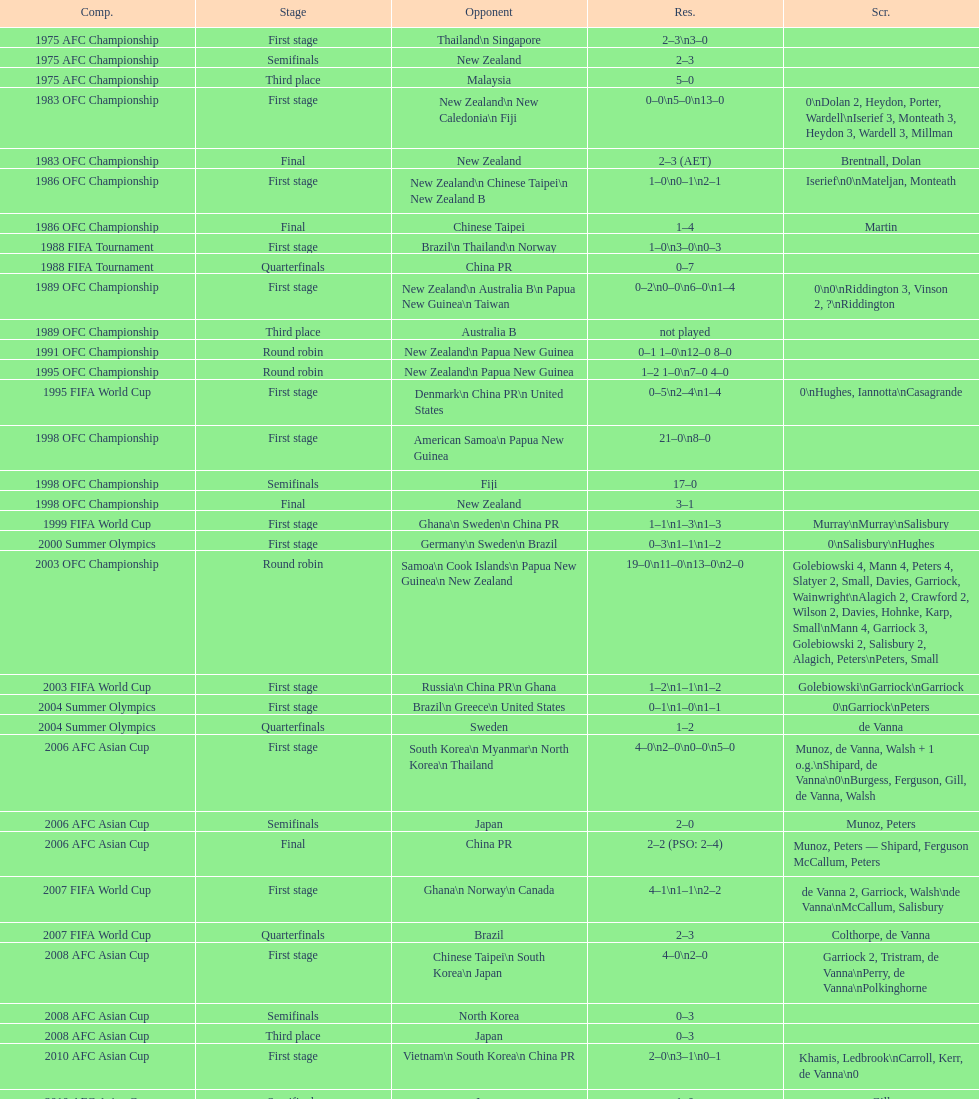What is the variation in the number of goals scored at the 1999 fifa world cup compared to the 2000 summer olympics? 2. 